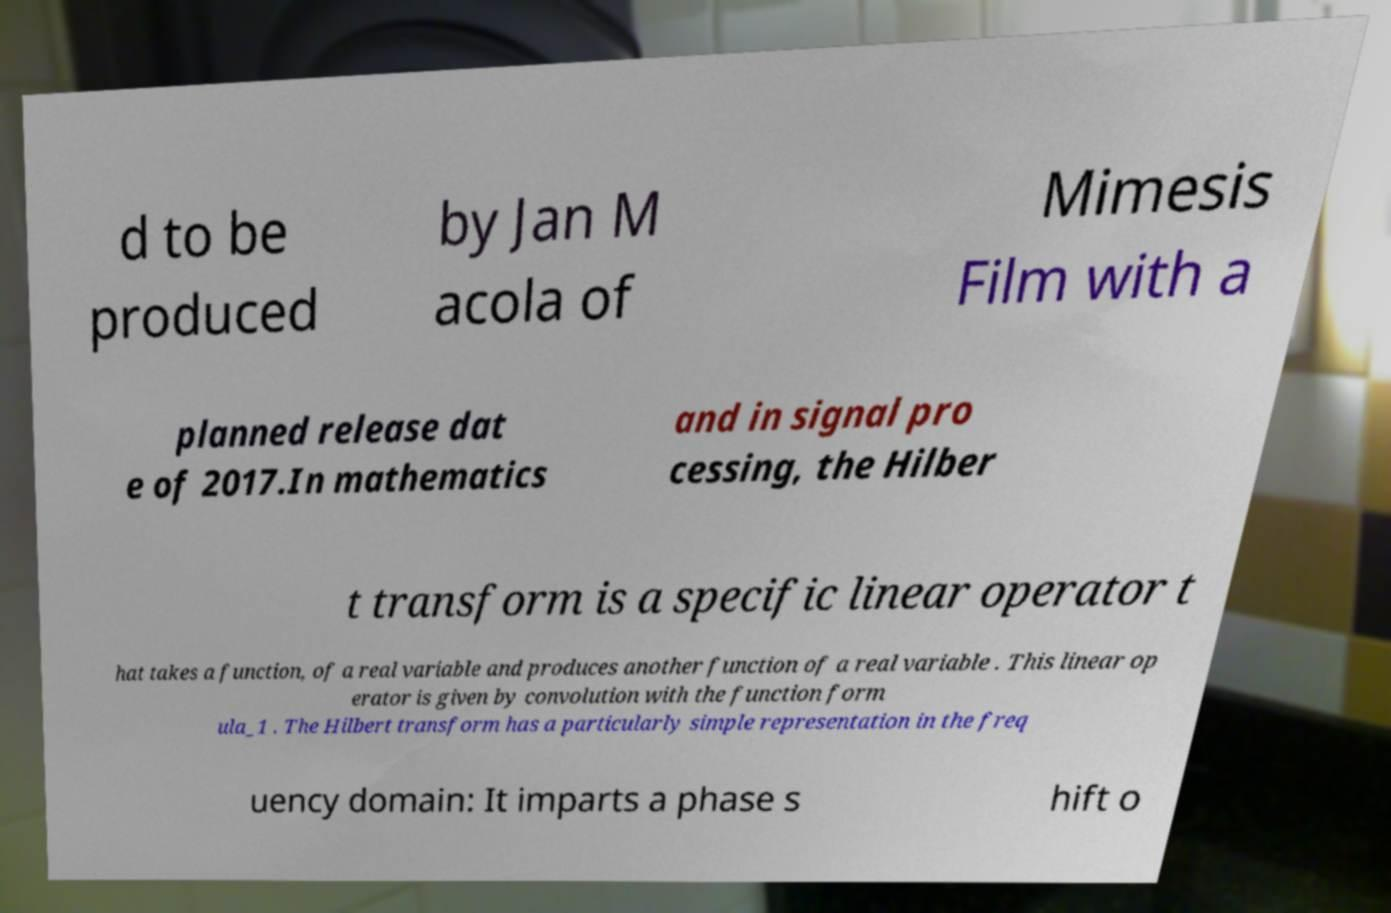There's text embedded in this image that I need extracted. Can you transcribe it verbatim? d to be produced by Jan M acola of Mimesis Film with a planned release dat e of 2017.In mathematics and in signal pro cessing, the Hilber t transform is a specific linear operator t hat takes a function, of a real variable and produces another function of a real variable . This linear op erator is given by convolution with the function form ula_1 . The Hilbert transform has a particularly simple representation in the freq uency domain: It imparts a phase s hift o 